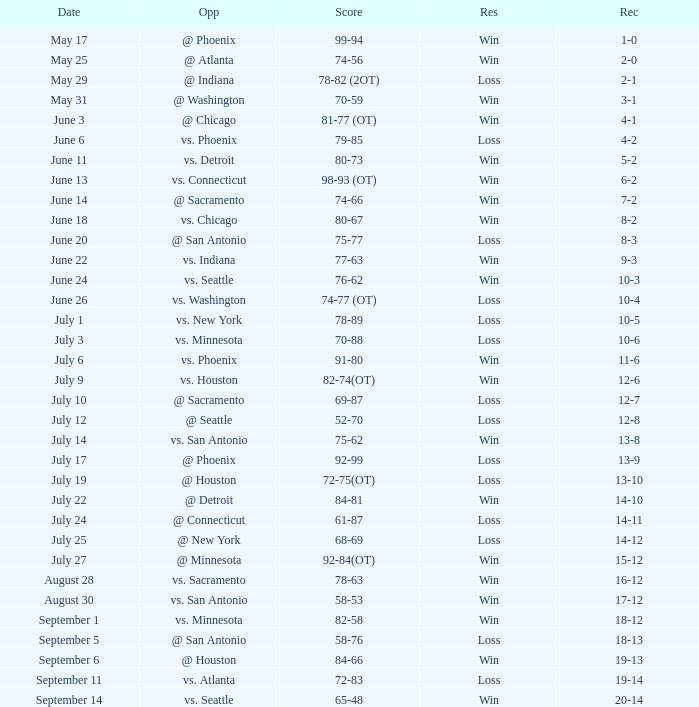What is the Opponent of the game with a Score of 74-66? @ Sacramento. 